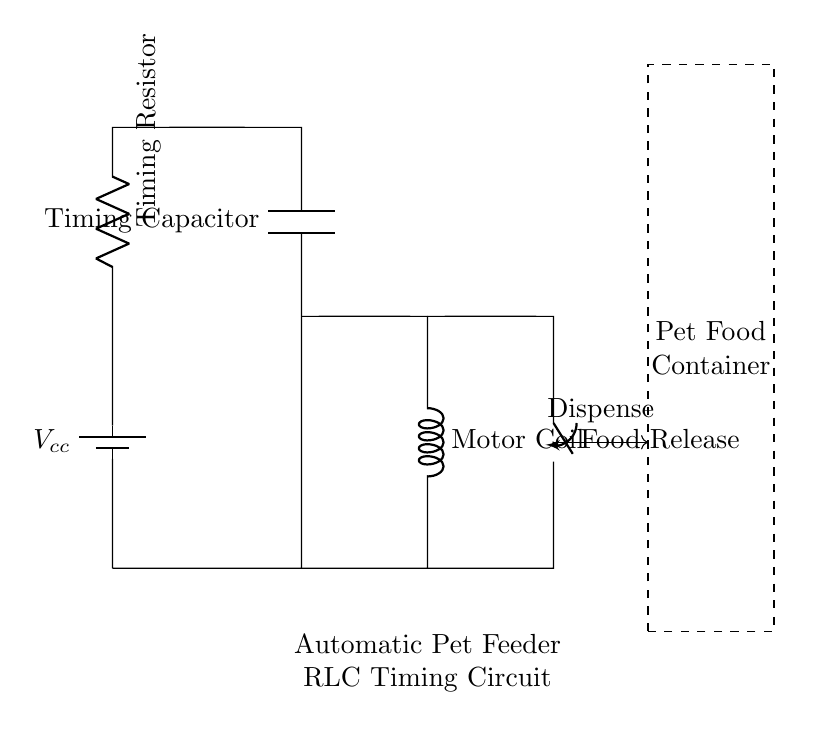What is the primary function of the timing resistor? The timing resistor controls the discharge time of the capacitor, influencing the timing interval between food dispensing.
Answer: Timing What component is used to release food? The component responsible for the food release is the switch. This allows control over when to dispense food.
Answer: Switch How many main components are present in the RLC circuit? The RLC circuit consists of three main components: a resistor, an inductor, and a capacitor. However, the diagram primarily shows a resistor, a motor (which functions as the inductor), and a capacitor.
Answer: Three What role does the timing capacitor play in this circuit? The timing capacitor works in conjunction with the resistor to create a delay before the switch activates, managing the timing of the food dispensing process.
Answer: Delay What is the voltage source in the circuit? The voltage source is represented by the battery, which provides the necessary voltage for the entire circuit operation.
Answer: Battery Which component in the circuit has a coil? The motor coil is the component that includes a coil, which can create a magnetic field when current flows through it, thus driving the food dispensing mechanism.
Answer: Motor coil What effect does the inductor (motor coil) have on the timing of the circuit? The inductor affects the timing by storing energy and delaying the current changes in the circuit, which can be crucial for controlling the release timing of the food from the feeder.
Answer: Current delay 